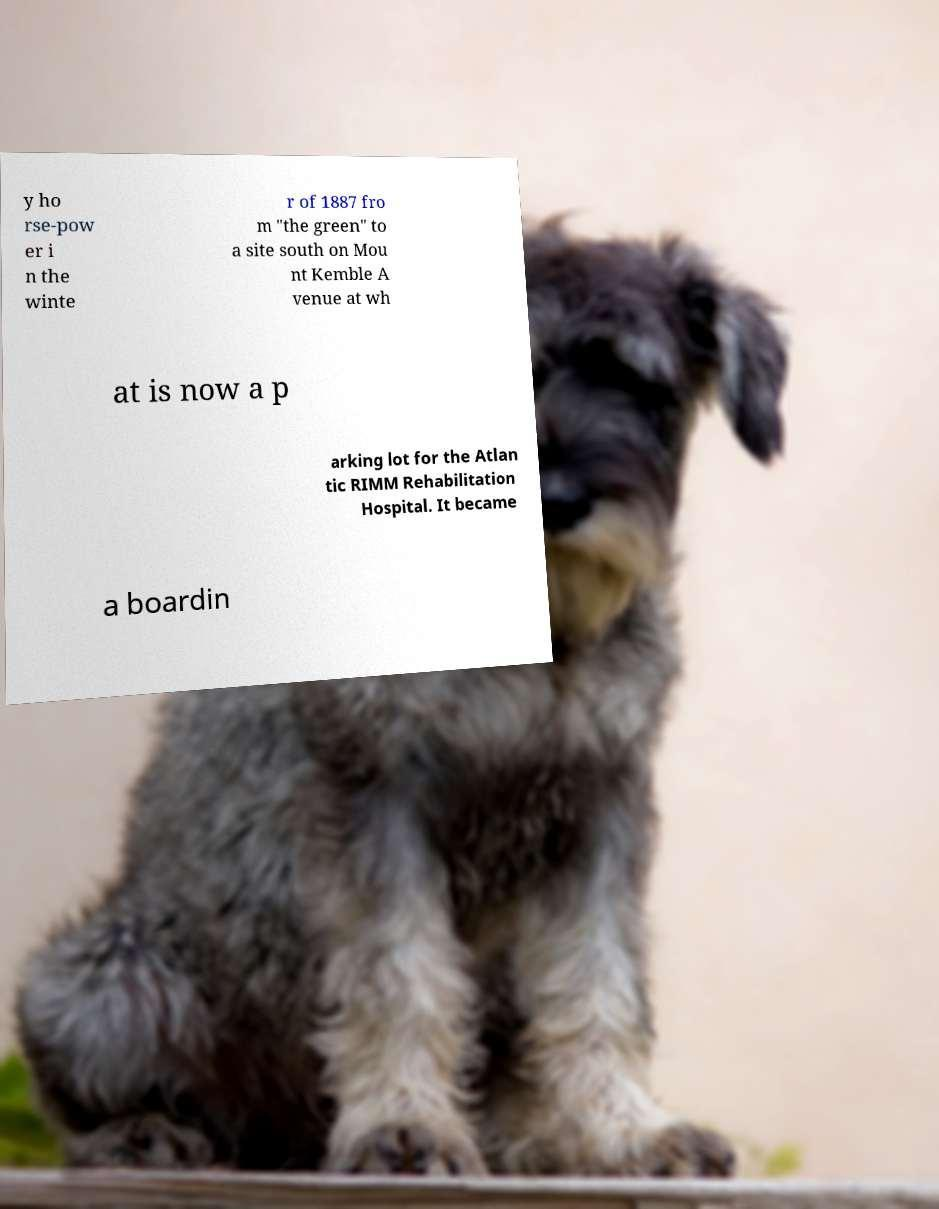Can you accurately transcribe the text from the provided image for me? y ho rse-pow er i n the winte r of 1887 fro m "the green" to a site south on Mou nt Kemble A venue at wh at is now a p arking lot for the Atlan tic RIMM Rehabilitation Hospital. It became a boardin 